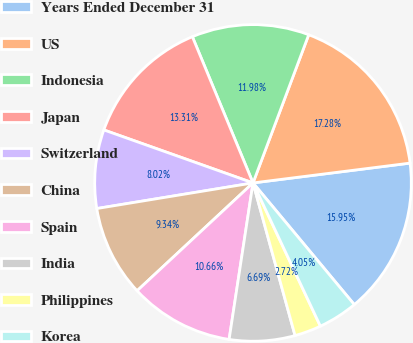<chart> <loc_0><loc_0><loc_500><loc_500><pie_chart><fcel>Years Ended December 31<fcel>US<fcel>Indonesia<fcel>Japan<fcel>Switzerland<fcel>China<fcel>Spain<fcel>India<fcel>Philippines<fcel>Korea<nl><fcel>15.95%<fcel>17.28%<fcel>11.98%<fcel>13.31%<fcel>8.02%<fcel>9.34%<fcel>10.66%<fcel>6.69%<fcel>2.72%<fcel>4.05%<nl></chart> 